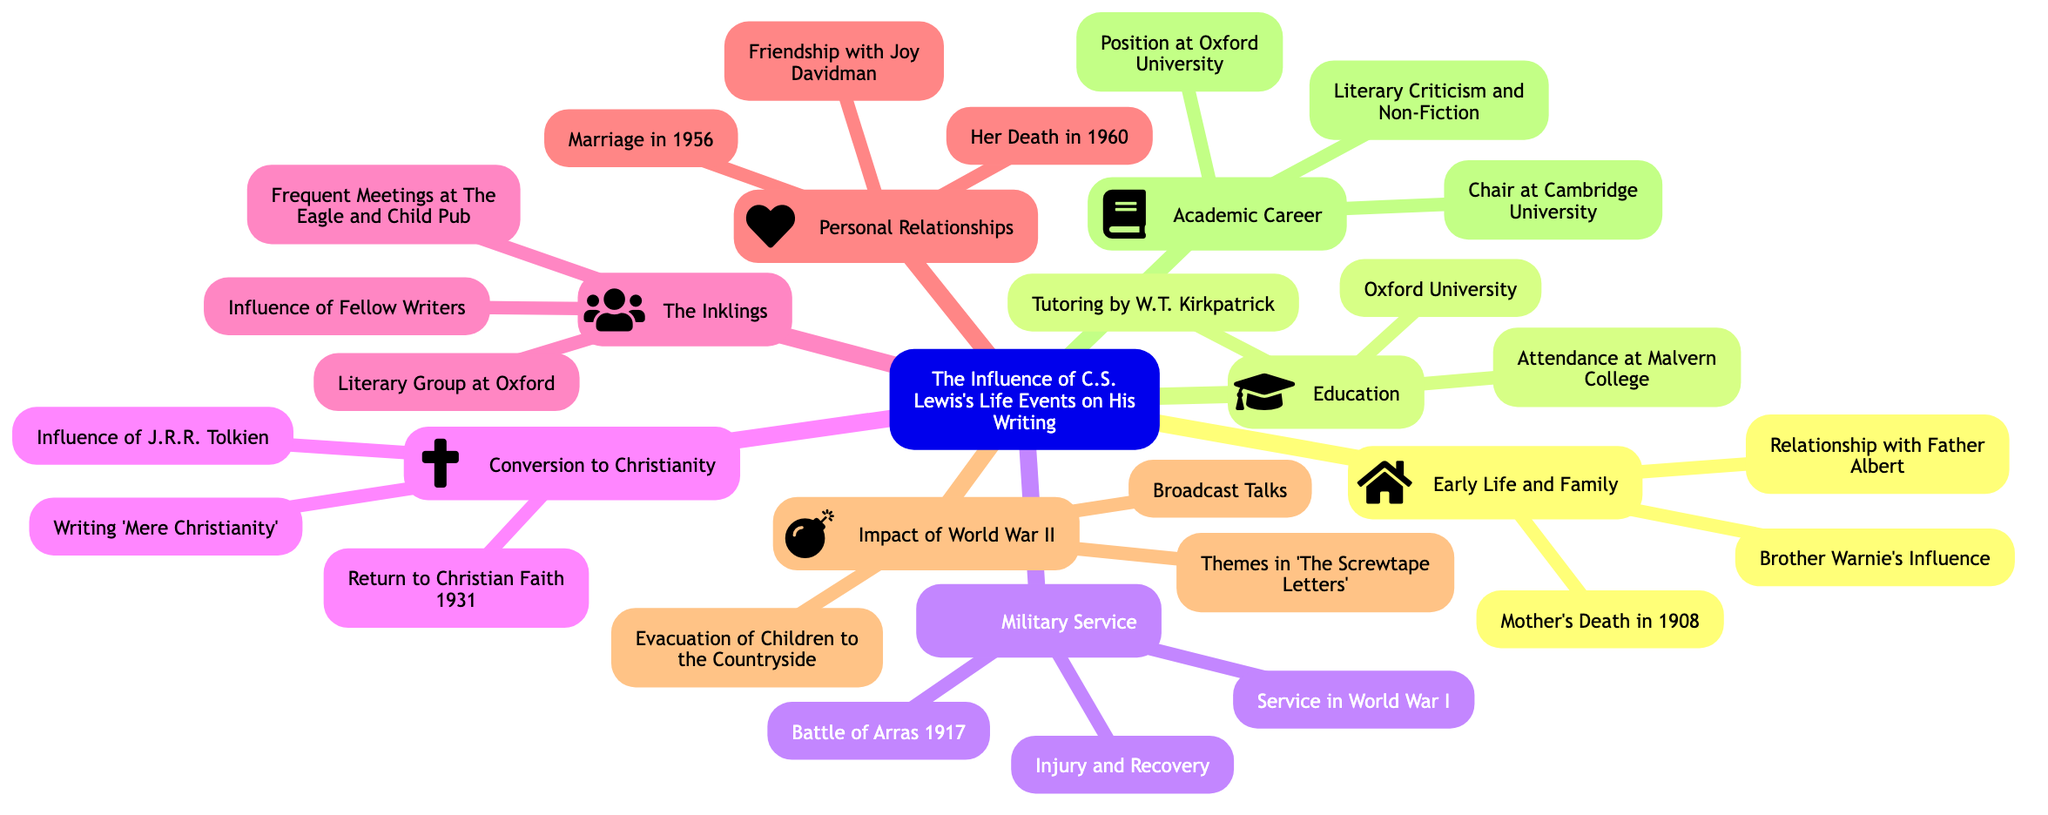What is the central topic of the mind map? The central topic is stated at the root of the mind map, specifically labeled as "The Influence of C.S. Lewis's Life Events on His Writing."
Answer: The Influence of C.S. Lewis's Life Events on His Writing How many subtopics are there in the diagram? By counting the distinct subtopic nodes branching from the central topic, we find there are eight subtopics.
Answer: 8 Which literary group did C.S. Lewis belong to? Among the subtopics, one specifically mentions "The Inklings," which denotes the literary group he was part of at Oxford.
Answer: The Inklings What event influenced C.S. Lewis's conversion to Christianity? The subtopic "Conversion to Christianity" highlights "Influence of J.R.R. Tolkien" as a significant factor in this life change.
Answer: Influence of J.R.R. Tolkien What significant event occurred in 1917 during Lewis's military service? Within the "Military Service" subtopic, the "Battle of Arras 1917" is specifically noted as a key event of that year related to his service.
Answer: Battle of Arras 1917 How did World War II impact Lewis's writing? The subtopic "Impact of World War II" lists "Themes in 'The Screwtape Letters'" indicating that the war had a direct influence on the themes present in his writings.
Answer: Themes in 'The Screwtape Letters' What personal relationship significantly affected Lewis's life and work? The "Personal Relationships" subtopic mentions "Friendship with Joy Davidman," indicating her importance in his life, particularly regarding his writing.
Answer: Friendship with Joy Davidman Which two universities did C.S. Lewis have positions at? The subtopic "Academic Career" mentions both "Position at Oxford University" and "Chair at Cambridge University" as roles he held, indicating the institutions of his academic pursuits.
Answer: Oxford University, Cambridge University 